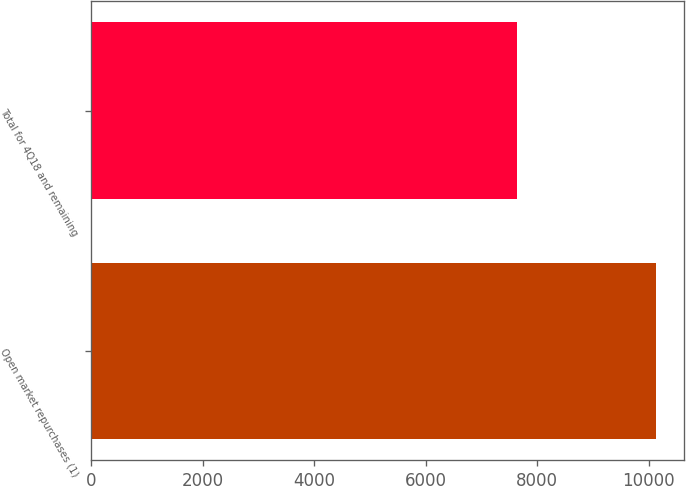Convert chart to OTSL. <chart><loc_0><loc_0><loc_500><loc_500><bar_chart><fcel>Open market repurchases (1)<fcel>Total for 4Q18 and remaining<nl><fcel>10127<fcel>7630<nl></chart> 